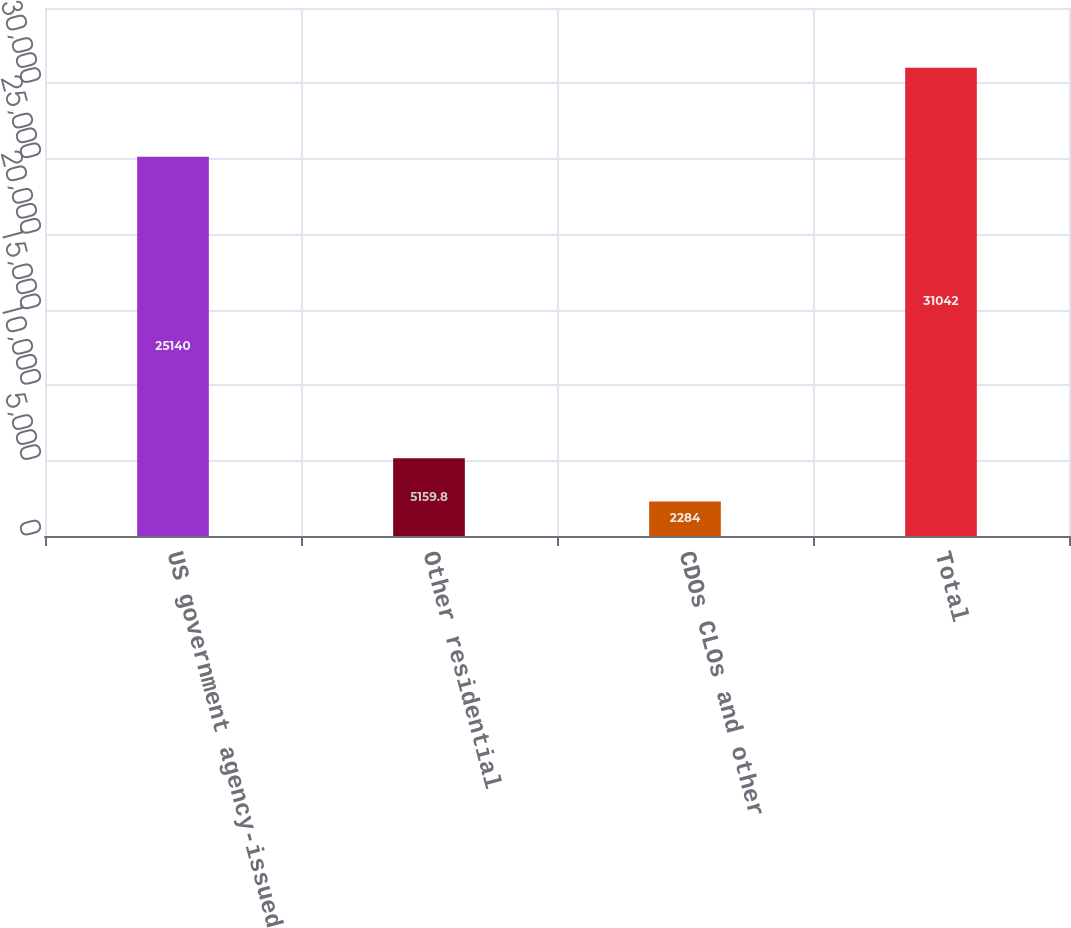<chart> <loc_0><loc_0><loc_500><loc_500><bar_chart><fcel>US government agency-issued<fcel>Other residential<fcel>CDOs CLOs and other<fcel>Total<nl><fcel>25140<fcel>5159.8<fcel>2284<fcel>31042<nl></chart> 